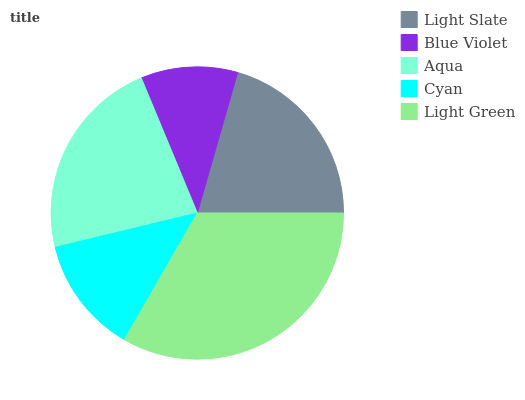Is Blue Violet the minimum?
Answer yes or no. Yes. Is Light Green the maximum?
Answer yes or no. Yes. Is Aqua the minimum?
Answer yes or no. No. Is Aqua the maximum?
Answer yes or no. No. Is Aqua greater than Blue Violet?
Answer yes or no. Yes. Is Blue Violet less than Aqua?
Answer yes or no. Yes. Is Blue Violet greater than Aqua?
Answer yes or no. No. Is Aqua less than Blue Violet?
Answer yes or no. No. Is Light Slate the high median?
Answer yes or no. Yes. Is Light Slate the low median?
Answer yes or no. Yes. Is Light Green the high median?
Answer yes or no. No. Is Aqua the low median?
Answer yes or no. No. 